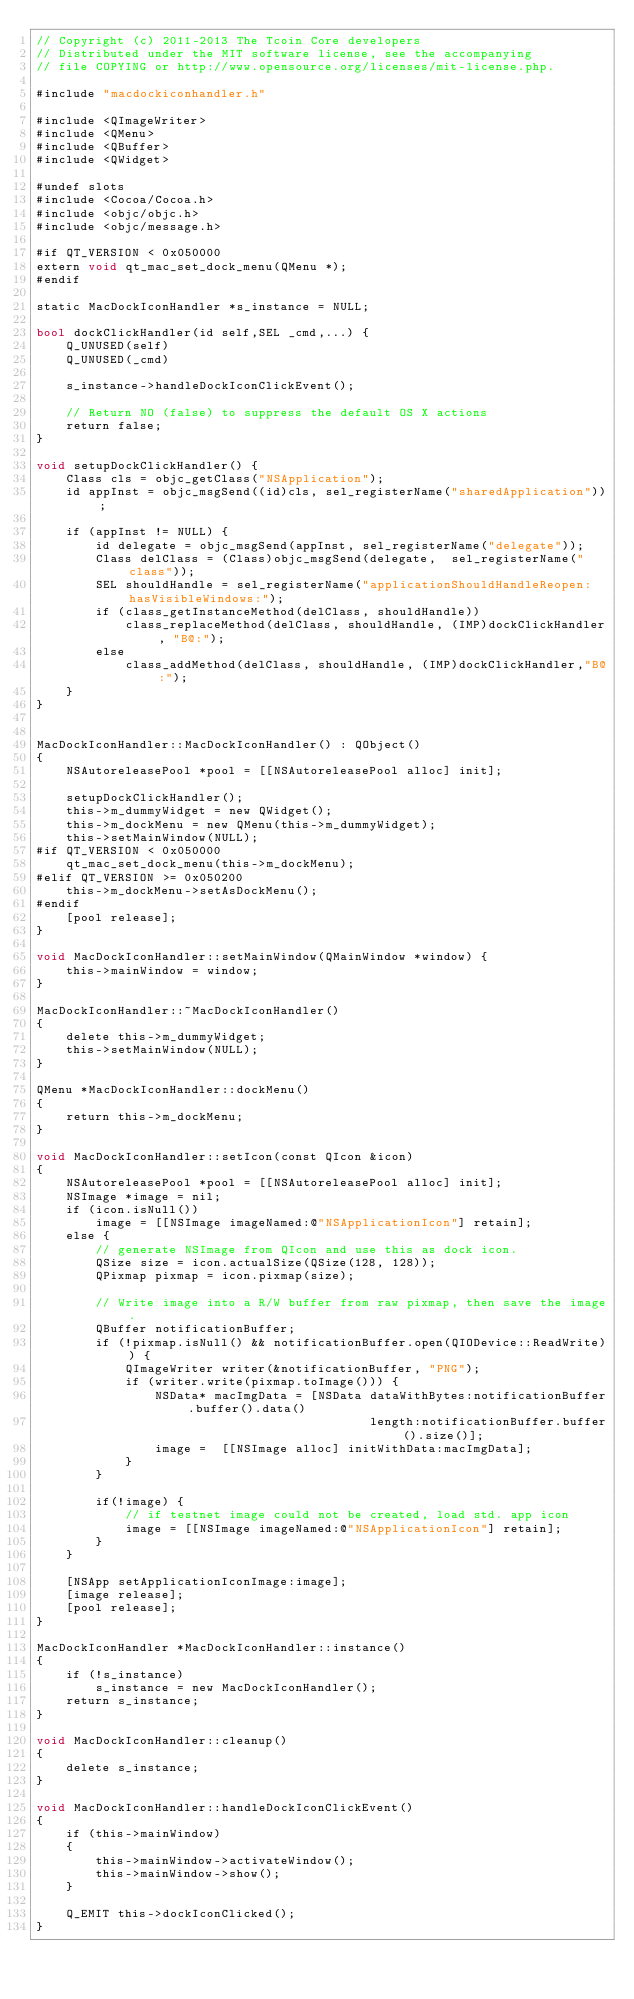Convert code to text. <code><loc_0><loc_0><loc_500><loc_500><_ObjectiveC_>// Copyright (c) 2011-2013 The Tcoin Core developers
// Distributed under the MIT software license, see the accompanying
// file COPYING or http://www.opensource.org/licenses/mit-license.php.

#include "macdockiconhandler.h"

#include <QImageWriter>
#include <QMenu>
#include <QBuffer>
#include <QWidget>

#undef slots
#include <Cocoa/Cocoa.h>
#include <objc/objc.h>
#include <objc/message.h>

#if QT_VERSION < 0x050000
extern void qt_mac_set_dock_menu(QMenu *);
#endif

static MacDockIconHandler *s_instance = NULL;

bool dockClickHandler(id self,SEL _cmd,...) {
    Q_UNUSED(self)
    Q_UNUSED(_cmd)
    
    s_instance->handleDockIconClickEvent();
    
    // Return NO (false) to suppress the default OS X actions
    return false;
}

void setupDockClickHandler() {
    Class cls = objc_getClass("NSApplication");
    id appInst = objc_msgSend((id)cls, sel_registerName("sharedApplication"));
    
    if (appInst != NULL) {
        id delegate = objc_msgSend(appInst, sel_registerName("delegate"));
        Class delClass = (Class)objc_msgSend(delegate,  sel_registerName("class"));
        SEL shouldHandle = sel_registerName("applicationShouldHandleReopen:hasVisibleWindows:");
        if (class_getInstanceMethod(delClass, shouldHandle))
            class_replaceMethod(delClass, shouldHandle, (IMP)dockClickHandler, "B@:");
        else
            class_addMethod(delClass, shouldHandle, (IMP)dockClickHandler,"B@:");
    }
}


MacDockIconHandler::MacDockIconHandler() : QObject()
{
    NSAutoreleasePool *pool = [[NSAutoreleasePool alloc] init];

    setupDockClickHandler();
    this->m_dummyWidget = new QWidget();
    this->m_dockMenu = new QMenu(this->m_dummyWidget);
    this->setMainWindow(NULL);
#if QT_VERSION < 0x050000
    qt_mac_set_dock_menu(this->m_dockMenu);
#elif QT_VERSION >= 0x050200
    this->m_dockMenu->setAsDockMenu();
#endif
    [pool release];
}

void MacDockIconHandler::setMainWindow(QMainWindow *window) {
    this->mainWindow = window;
}

MacDockIconHandler::~MacDockIconHandler()
{
    delete this->m_dummyWidget;
    this->setMainWindow(NULL);
}

QMenu *MacDockIconHandler::dockMenu()
{
    return this->m_dockMenu;
}

void MacDockIconHandler::setIcon(const QIcon &icon)
{
    NSAutoreleasePool *pool = [[NSAutoreleasePool alloc] init];
    NSImage *image = nil;
    if (icon.isNull())
        image = [[NSImage imageNamed:@"NSApplicationIcon"] retain];
    else {
        // generate NSImage from QIcon and use this as dock icon.
        QSize size = icon.actualSize(QSize(128, 128));
        QPixmap pixmap = icon.pixmap(size);

        // Write image into a R/W buffer from raw pixmap, then save the image.
        QBuffer notificationBuffer;
        if (!pixmap.isNull() && notificationBuffer.open(QIODevice::ReadWrite)) {
            QImageWriter writer(&notificationBuffer, "PNG");
            if (writer.write(pixmap.toImage())) {
                NSData* macImgData = [NSData dataWithBytes:notificationBuffer.buffer().data()
                                             length:notificationBuffer.buffer().size()];
                image =  [[NSImage alloc] initWithData:macImgData];
            }
        }

        if(!image) {
            // if testnet image could not be created, load std. app icon
            image = [[NSImage imageNamed:@"NSApplicationIcon"] retain];
        }
    }

    [NSApp setApplicationIconImage:image];
    [image release];
    [pool release];
}

MacDockIconHandler *MacDockIconHandler::instance()
{
    if (!s_instance)
        s_instance = new MacDockIconHandler();
    return s_instance;
}

void MacDockIconHandler::cleanup()
{
    delete s_instance;
}

void MacDockIconHandler::handleDockIconClickEvent()
{
    if (this->mainWindow)
    {
        this->mainWindow->activateWindow();
        this->mainWindow->show();
    }

    Q_EMIT this->dockIconClicked();
}
</code> 